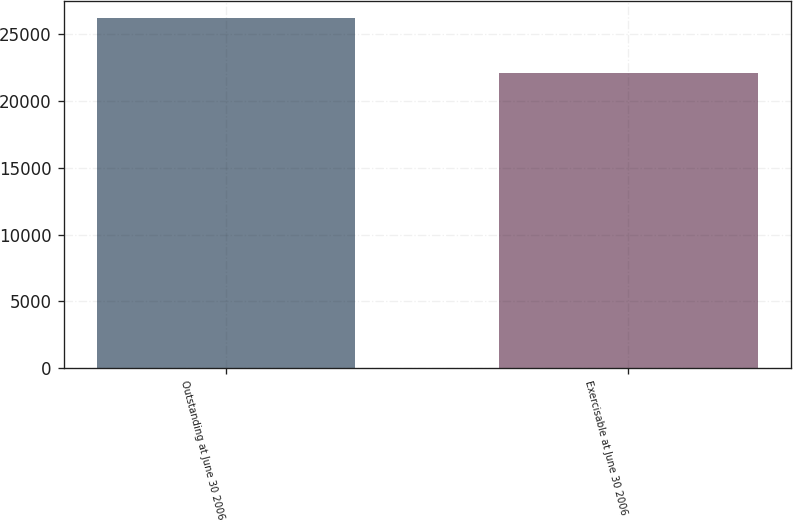<chart> <loc_0><loc_0><loc_500><loc_500><bar_chart><fcel>Outstanding at June 30 2006<fcel>Exercisable at June 30 2006<nl><fcel>26215.7<fcel>22095.5<nl></chart> 